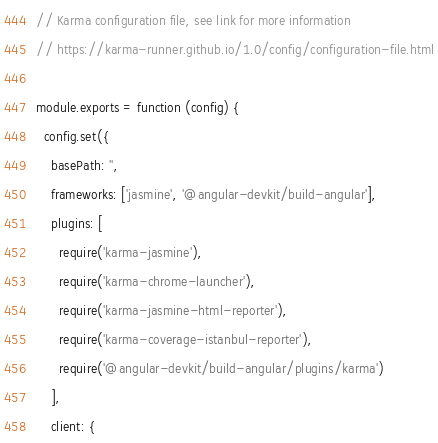Convert code to text. <code><loc_0><loc_0><loc_500><loc_500><_JavaScript_>// Karma configuration file, see link for more information
// https://karma-runner.github.io/1.0/config/configuration-file.html

module.exports = function (config) {
  config.set({
    basePath: '',
    frameworks: ['jasmine', '@angular-devkit/build-angular'],
    plugins: [
      require('karma-jasmine'),
      require('karma-chrome-launcher'),
      require('karma-jasmine-html-reporter'),
      require('karma-coverage-istanbul-reporter'),
      require('@angular-devkit/build-angular/plugins/karma')
    ],
    client: {</code> 